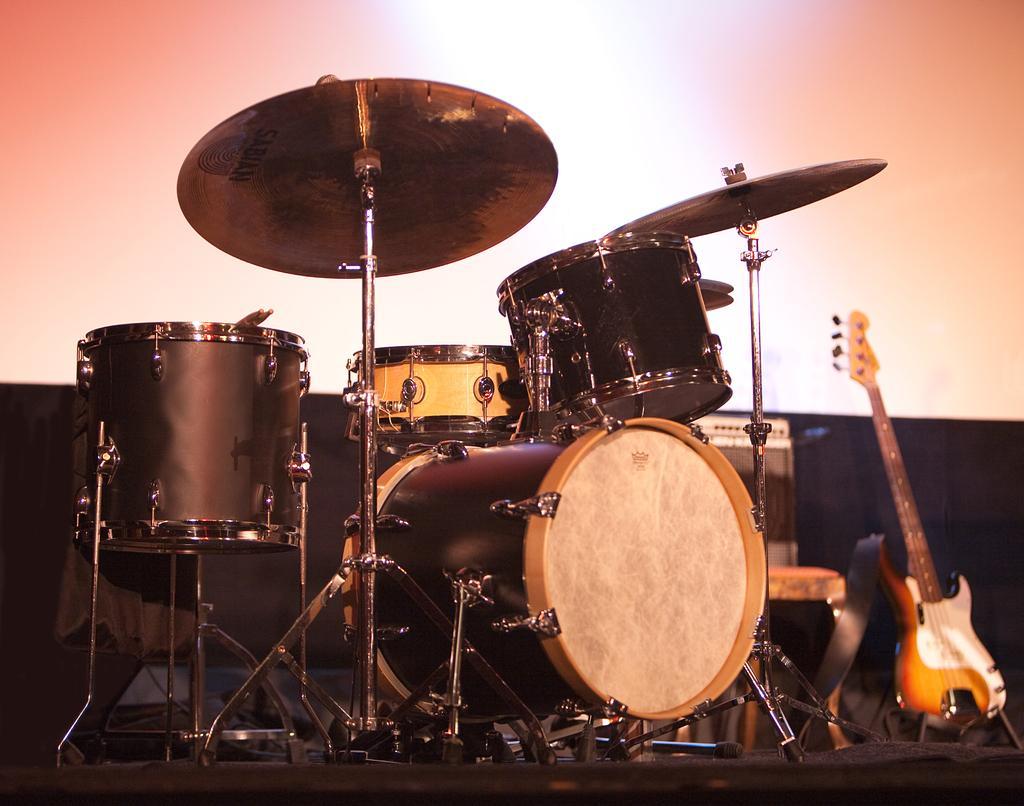In one or two sentences, can you explain what this image depicts? In this picture I can see that drums, guitar, piano and other musical instruments which are kept on the stage. In the background I can see the projector screen. 